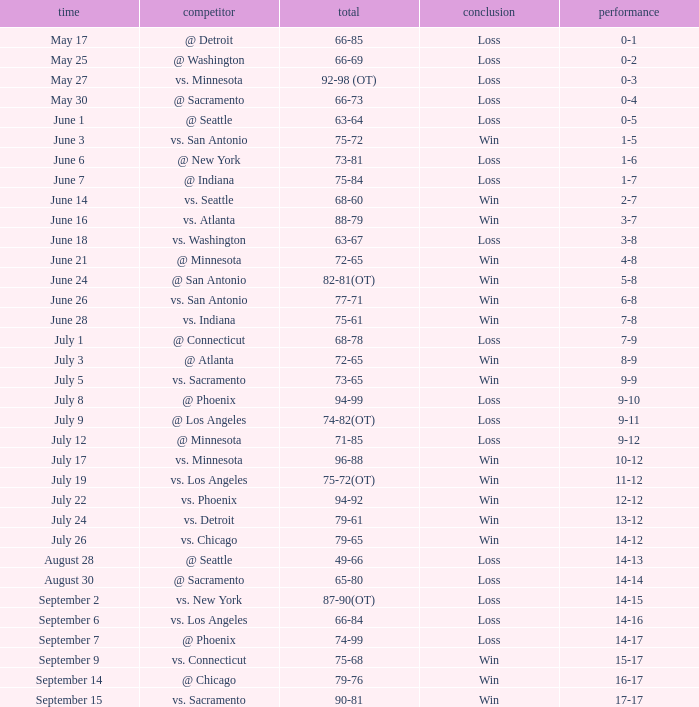What was the Result on July 24? Win. 